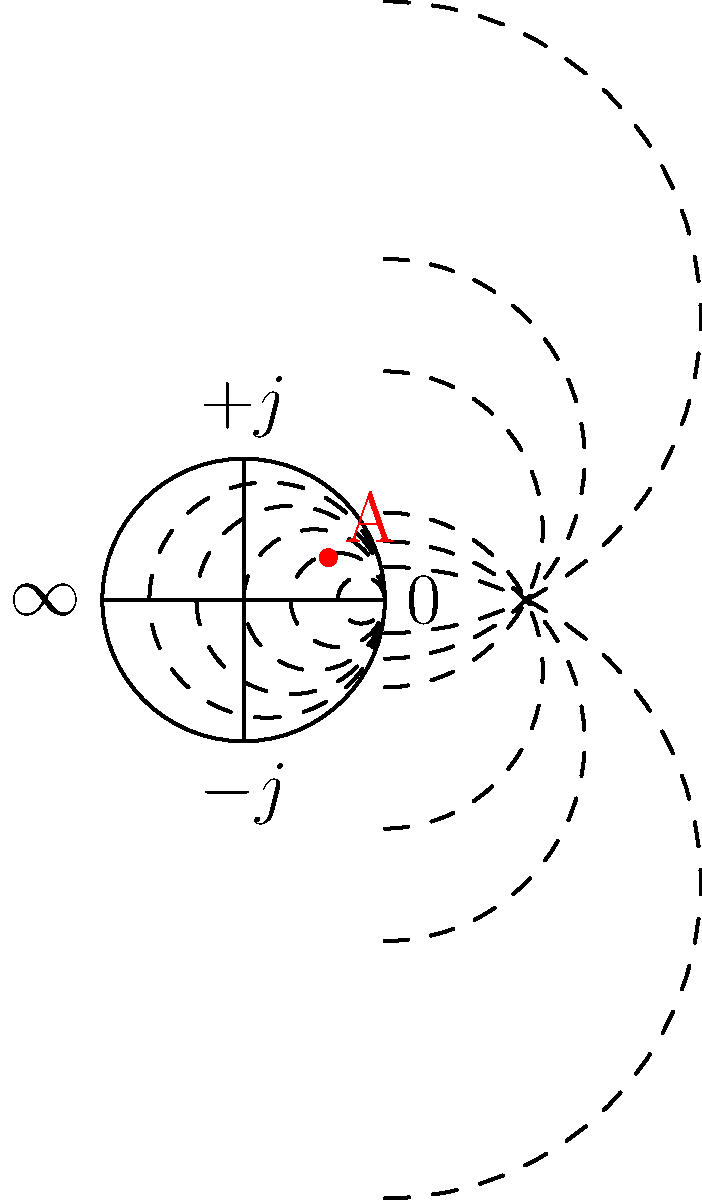In the Smith chart shown above, point A represents a specific impedance. What is the approximate normalized impedance (Z/Z₀) corresponding to this point? To determine the normalized impedance from a Smith chart:

1. Resistance (R/Z₀):
   - Observe that point A lies between the 0.5 and 1 constant resistance circles.
   - Estimate its position to be closer to 1, approximately 0.8.

2. Reactance (X/Z₀):
   - Notice that point A is above the horizontal axis, indicating positive reactance.
   - It appears to be between the 0.2 and 0.5 constant reactance arcs.
   - Estimate its position to be closer to 0.5, approximately 0.4.

3. Combine the resistance and reactance:
   The normalized impedance is expressed as Z/Z₀ = (R/Z₀) + j(X/Z₀).

Therefore, the approximate normalized impedance is:

Z/Z₀ ≈ 0.8 + j0.4

This format (a + jb) represents the complex impedance, where 'a' is the real part (resistance) and 'b' is the imaginary part (reactance).
Answer: 0.8 + j0.4 